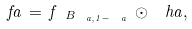Convert formula to latex. <formula><loc_0><loc_0><loc_500><loc_500>\ f a \, = \, f _ { \ B _ { \ a , 1 - \ a } } \, \odot \, \ h a ,</formula> 